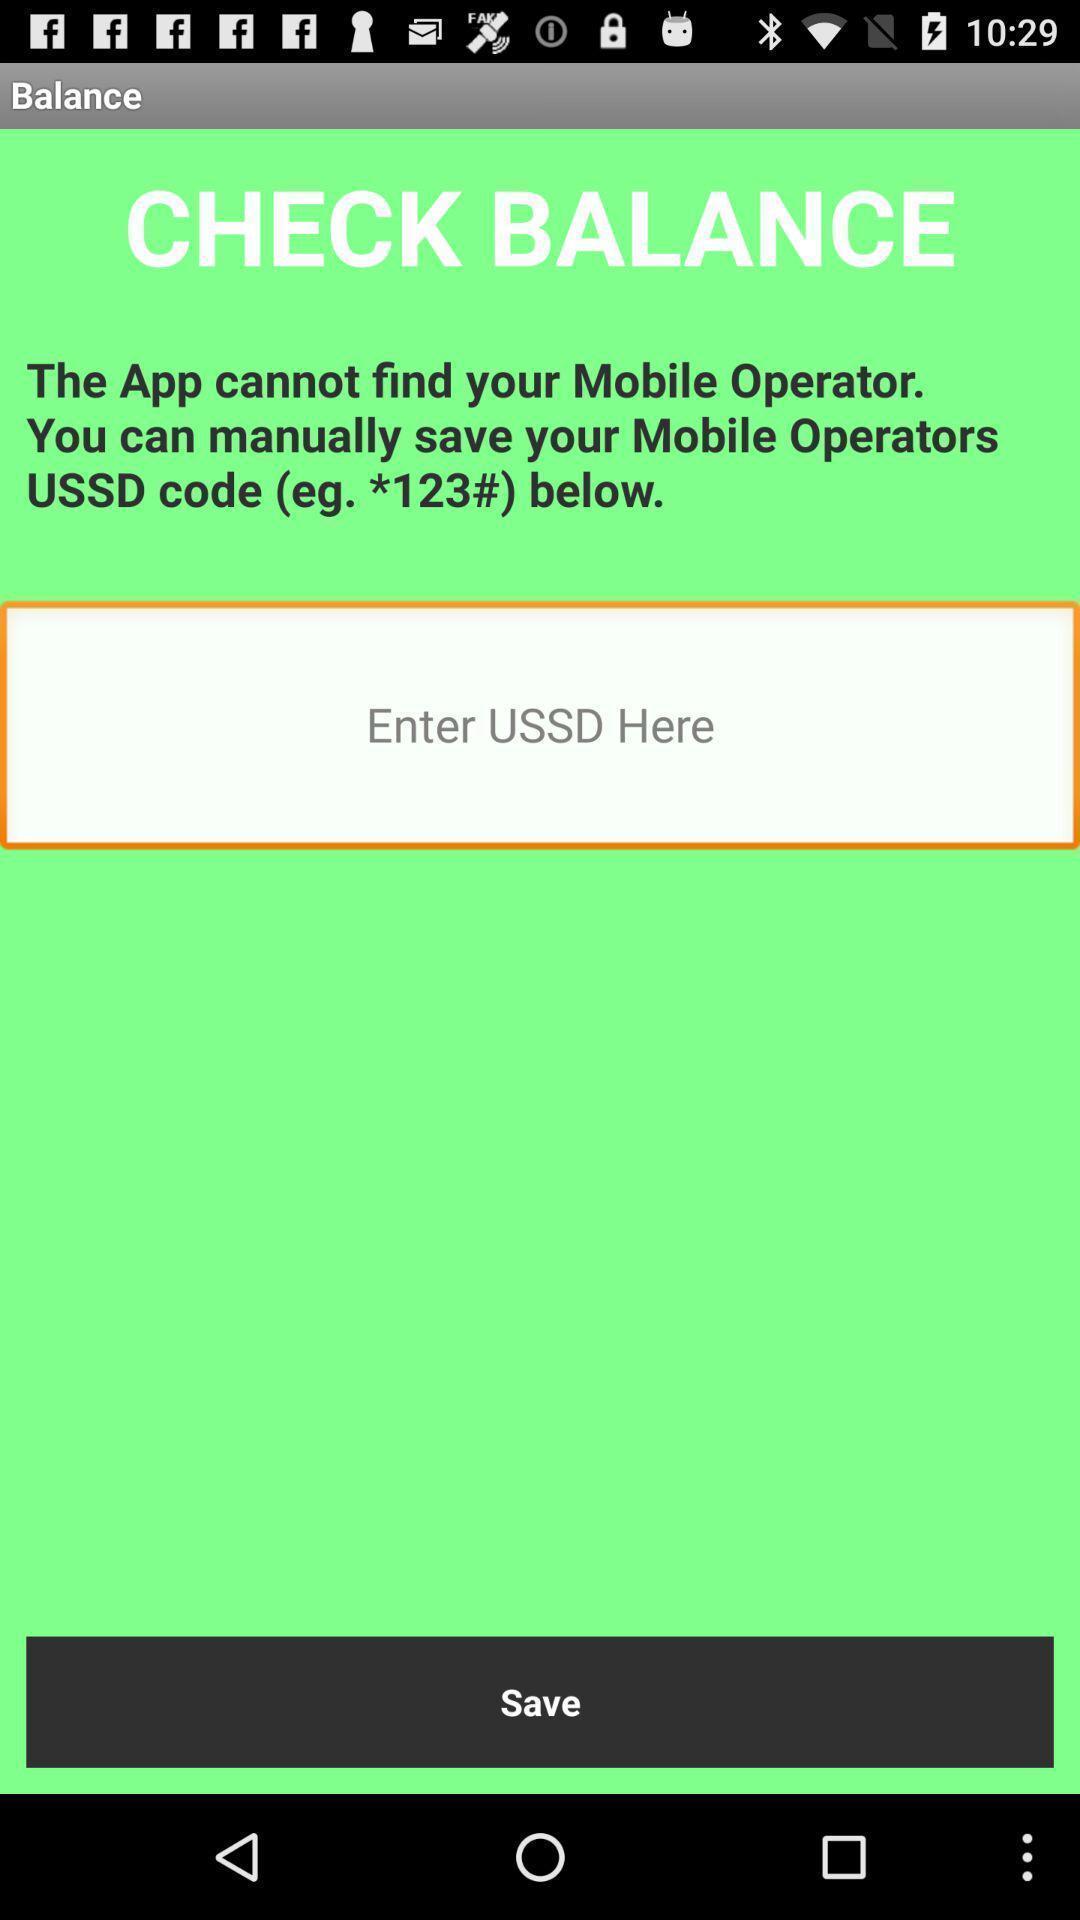Please provide a description for this image. Page displaying to enter code to view balance. 